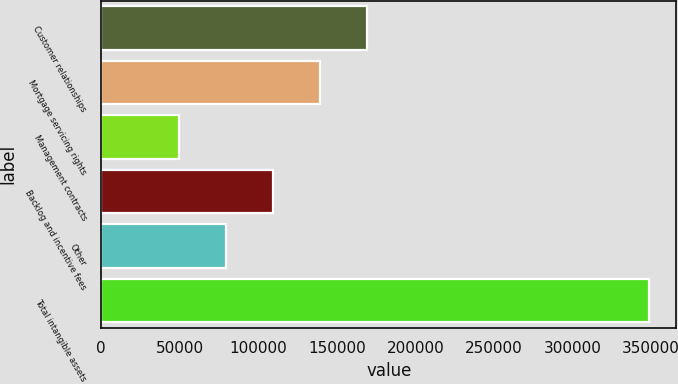<chart> <loc_0><loc_0><loc_500><loc_500><bar_chart><fcel>Customer relationships<fcel>Mortgage servicing rights<fcel>Management contracts<fcel>Backlog and incentive fees<fcel>Other<fcel>Total intangible assets<nl><fcel>169297<fcel>139419<fcel>49785<fcel>109541<fcel>79663.1<fcel>348566<nl></chart> 